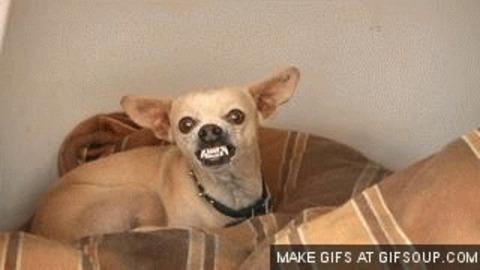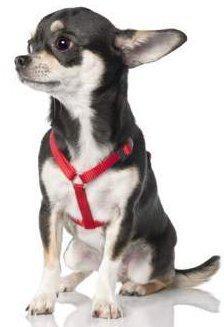The first image is the image on the left, the second image is the image on the right. Considering the images on both sides, is "In at least one image, the dog's teeth are not bared." valid? Answer yes or no. Yes. 